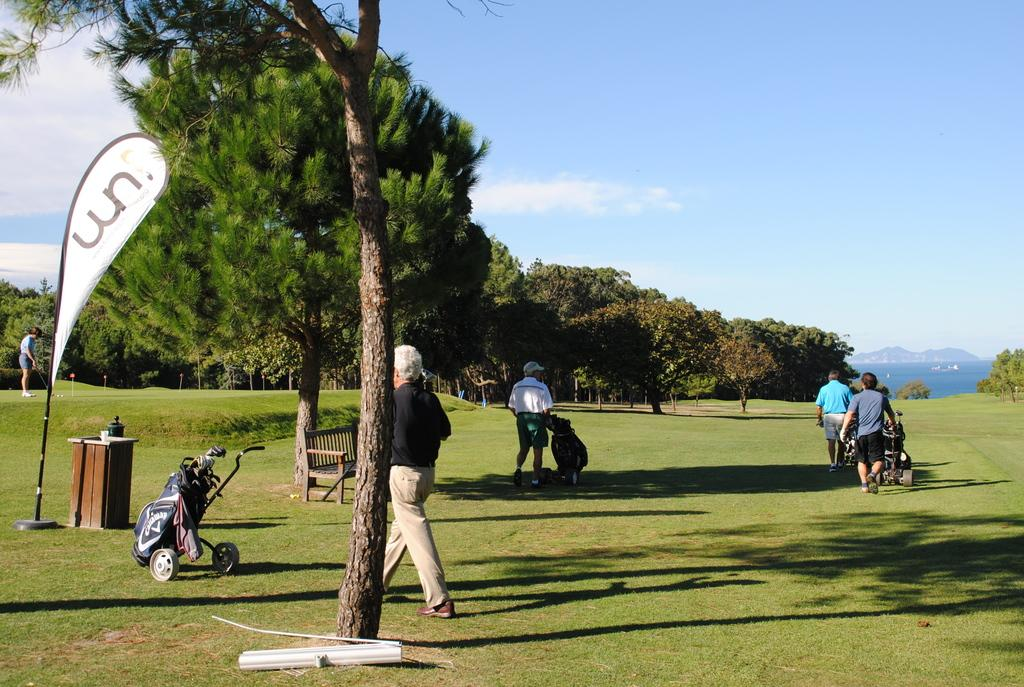How many people are in the image? There are persons standing in the image. What is the color and texture of the ground in the image? The ground is green and grassy. What can be seen in the background of the image? There are trees in the background of the image. What type of clouds can be seen in the image? There are no clouds visible in the image; it only shows persons standing on a green, grassy ground with trees in the background. 